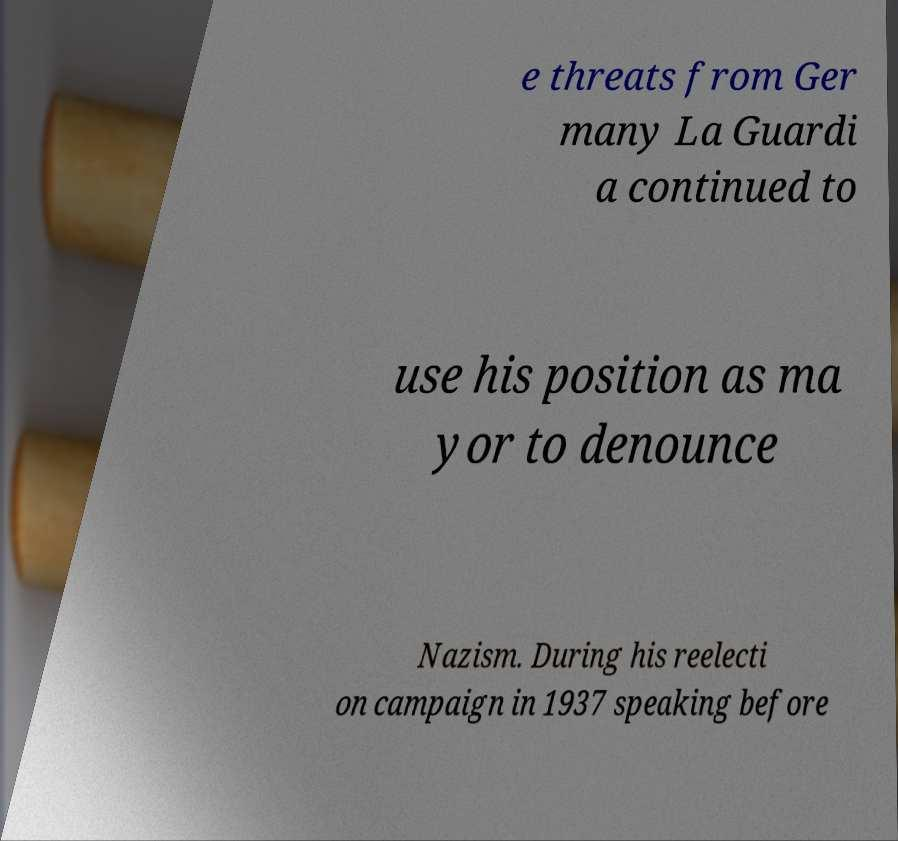Can you accurately transcribe the text from the provided image for me? e threats from Ger many La Guardi a continued to use his position as ma yor to denounce Nazism. During his reelecti on campaign in 1937 speaking before 